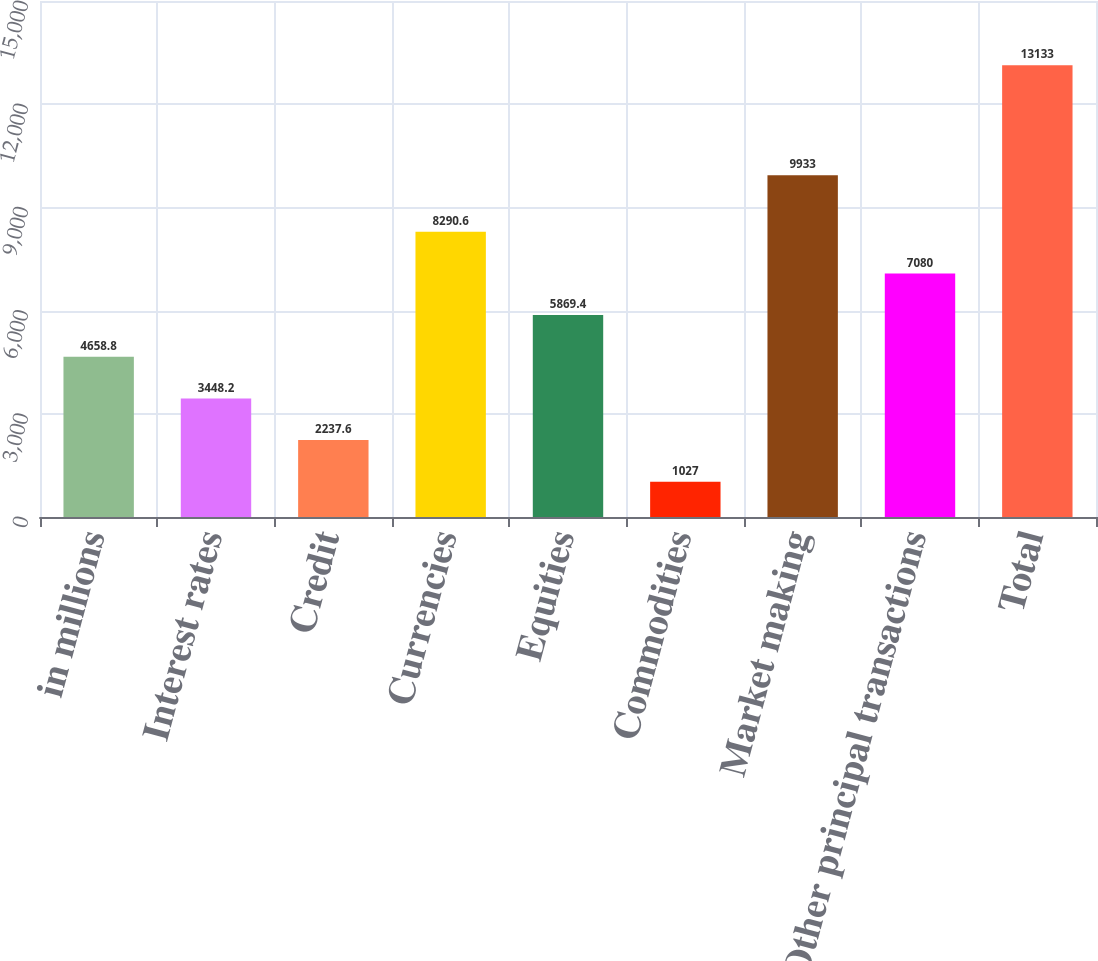<chart> <loc_0><loc_0><loc_500><loc_500><bar_chart><fcel>in millions<fcel>Interest rates<fcel>Credit<fcel>Currencies<fcel>Equities<fcel>Commodities<fcel>Market making<fcel>Other principal transactions<fcel>Total<nl><fcel>4658.8<fcel>3448.2<fcel>2237.6<fcel>8290.6<fcel>5869.4<fcel>1027<fcel>9933<fcel>7080<fcel>13133<nl></chart> 